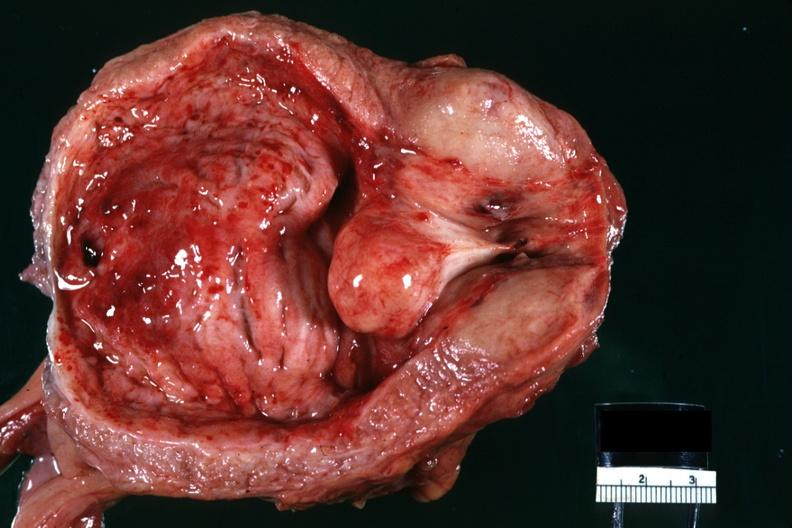s prostate present?
Answer the question using a single word or phrase. Yes 